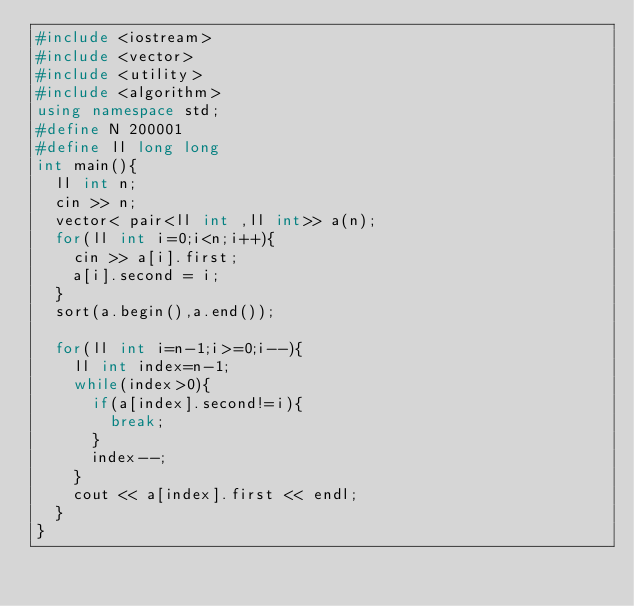<code> <loc_0><loc_0><loc_500><loc_500><_C++_>#include <iostream>
#include <vector>
#include <utility>
#include <algorithm>
using namespace std;
#define N 200001
#define ll long long
int main(){
	ll int n;
	cin >> n;
	vector< pair<ll int ,ll int>> a(n);
	for(ll int i=0;i<n;i++){
		cin >> a[i].first;
		a[i].second = i;
	}
	sort(a.begin(),a.end());

	for(ll int i=n-1;i>=0;i--){
		ll int index=n-1;
		while(index>0){
			if(a[index].second!=i){
				break;
			}
			index--;
		}
		cout << a[index].first << endl;
	}
}
</code> 